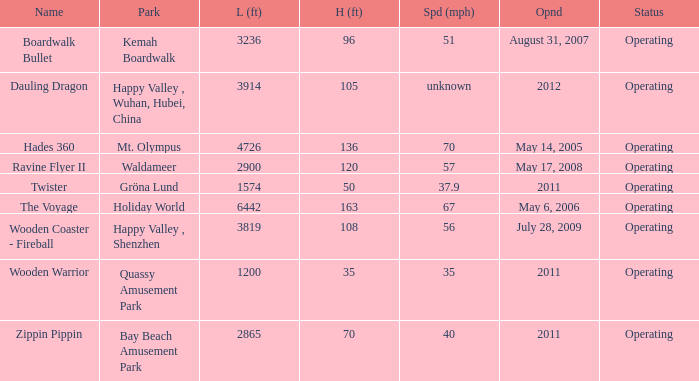How many parks is Zippin Pippin located in 1.0. 